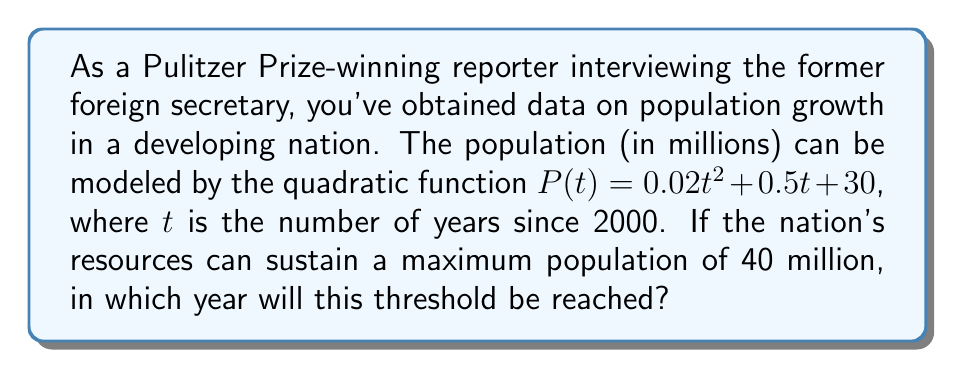Could you help me with this problem? 1) We need to solve the equation:
   $P(t) = 40$

2) Substitute the given function:
   $0.02t^2 + 0.5t + 30 = 40$

3) Rearrange to standard form:
   $0.02t^2 + 0.5t - 10 = 0$

4) This is a quadratic equation. We can solve it using the quadratic formula:
   $t = \frac{-b \pm \sqrt{b^2 - 4ac}}{2a}$

   Where $a = 0.02$, $b = 0.5$, and $c = -10$

5) Substitute these values:
   $t = \frac{-0.5 \pm \sqrt{0.5^2 - 4(0.02)(-10)}}{2(0.02)}$

6) Simplify:
   $t = \frac{-0.5 \pm \sqrt{0.25 + 0.8}}{0.04} = \frac{-0.5 \pm \sqrt{1.05}}{0.04}$

7) Calculate:
   $t \approx \frac{-0.5 \pm 1.0247}{0.04} \approx -12.5 \pm 25.6175$

8) This gives us two solutions:
   $t \approx 13.1175$ or $t \approx -38.1175$

9) Since we're dealing with future years and $t$ represents years since 2000, we take the positive solution.

10) Round to the nearest whole year:
    $t \approx 13$ years after 2000

11) Therefore, the year is 2000 + 13 = 2013
Answer: 2013 